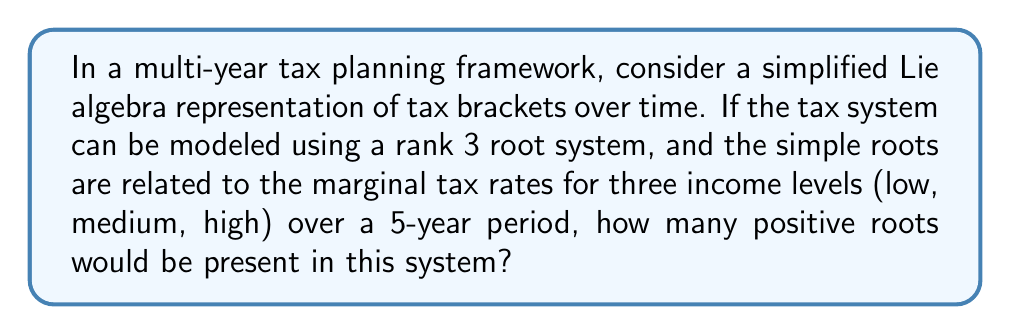Can you solve this math problem? To approach this problem, let's break it down into steps:

1) In Lie algebra, a rank 3 root system corresponds to a 3-dimensional space. The simple roots form a basis for this space.

2) In our tax planning analogy:
   - $\alpha_1$ represents the low income tax rate
   - $\alpha_2$ represents the medium income tax rate
   - $\alpha_3$ represents the high income tax rate

3) The positive roots in a rank 3 system include:
   - The 3 simple roots: $\alpha_1$, $\alpha_2$, $\alpha_3$
   - 3 roots that are sums of two simple roots: $\alpha_1 + \alpha_2$, $\alpha_2 + \alpha_3$, $\alpha_1 + \alpha_3$
   - 1 root that is the sum of all three simple roots: $\alpha_1 + \alpha_2 + \alpha_3$

4) Therefore, the total number of positive roots in a rank 3 system is:

   $$ 3 + 3 + 1 = 7 $$

5) In our tax planning context, these 7 positive roots could represent:
   - 3 individual tax rates (simple roots)
   - 3 combined effects of pairs of tax rates
   - 1 overall effect of all three tax rates

6) The 5-year period mentioned in the question doesn't affect the number of roots in the system, but it suggests that we're looking at how these tax rates and their interactions evolve over time.
Answer: The number of positive roots in this rank 3 root system representation of a multi-year tax planning framework is 7. 